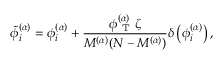<formula> <loc_0><loc_0><loc_500><loc_500>\tilde { \phi } _ { i } ^ { ( \alpha ) } = \phi _ { i } ^ { ( \alpha ) } + \frac { \phi _ { T } ^ { ( \alpha ) } \zeta } { M ^ { ( \alpha ) } ( N - M ^ { ( \alpha ) } ) } \delta \left ( \phi _ { i } ^ { ( \alpha ) } \right ) ,</formula> 